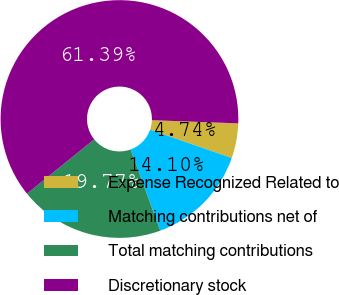Convert chart. <chart><loc_0><loc_0><loc_500><loc_500><pie_chart><fcel>Expense Recognized Related to<fcel>Matching contributions net of<fcel>Total matching contributions<fcel>Discretionary stock<nl><fcel>4.74%<fcel>14.1%<fcel>19.77%<fcel>61.39%<nl></chart> 